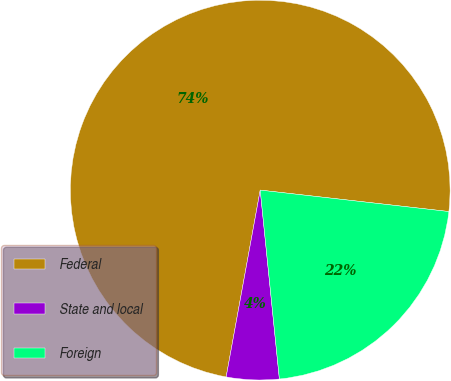<chart> <loc_0><loc_0><loc_500><loc_500><pie_chart><fcel>Federal<fcel>State and local<fcel>Foreign<nl><fcel>73.93%<fcel>4.48%<fcel>21.59%<nl></chart> 